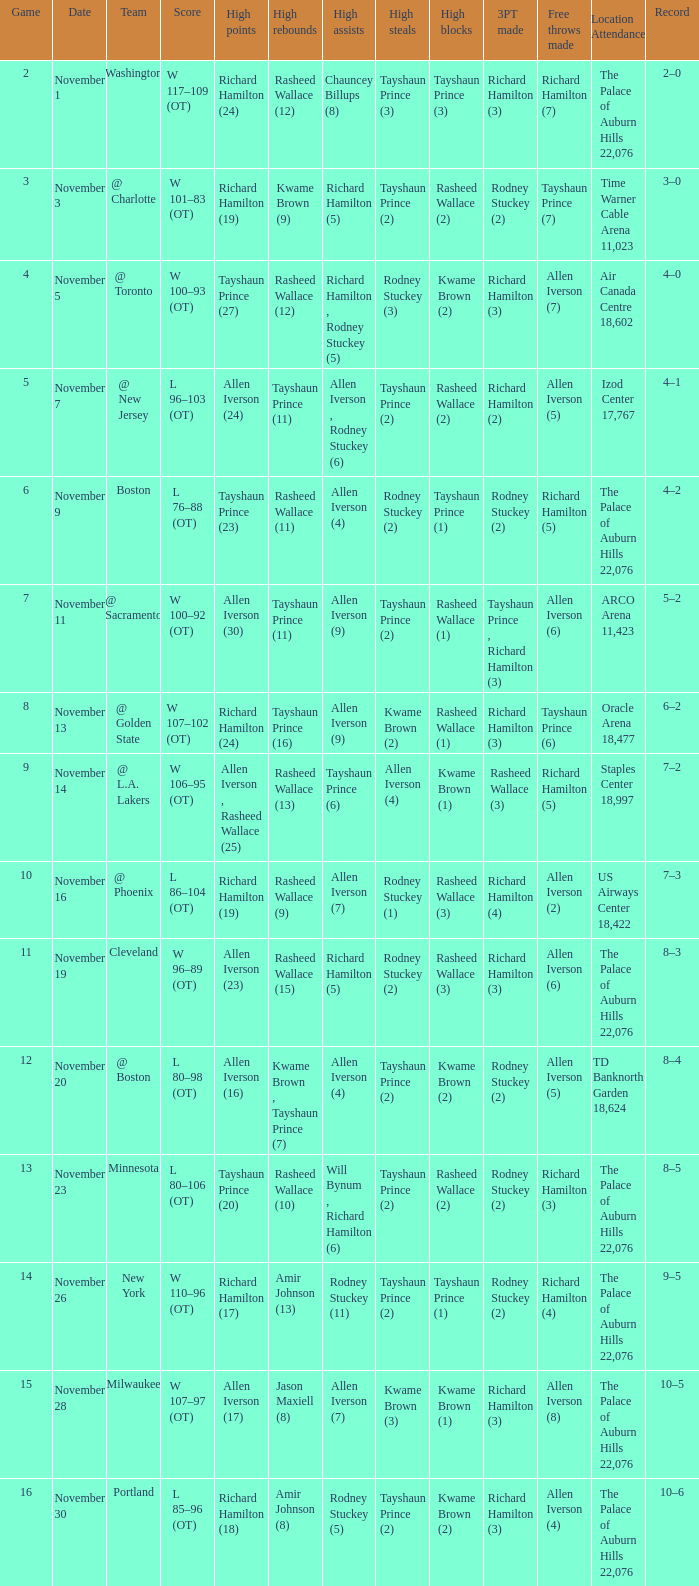What is Location Attendance, when High Points is "Allen Iverson (23)"? The Palace of Auburn Hills 22,076. 